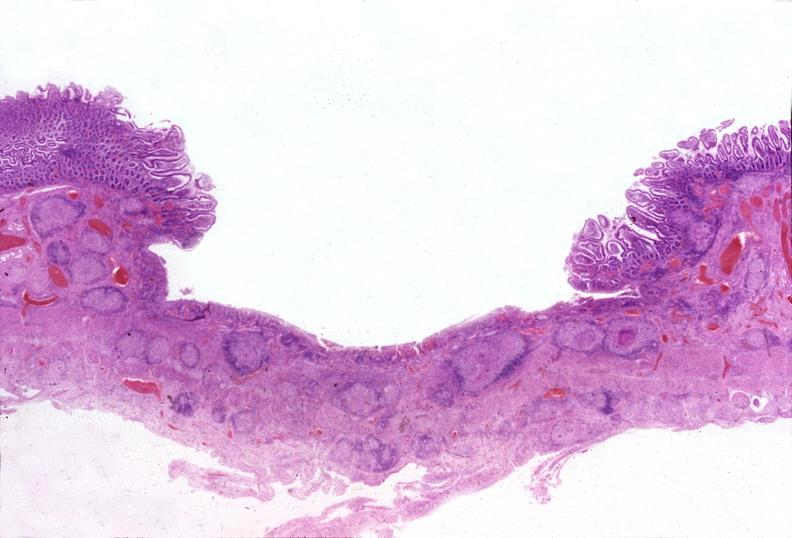s gastrointestinal present?
Answer the question using a single word or phrase. Yes 